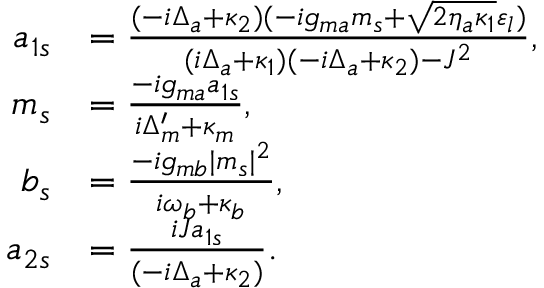Convert formula to latex. <formula><loc_0><loc_0><loc_500><loc_500>\begin{array} { r l } { a _ { 1 s } } & { = \frac { ( - i \Delta _ { a } + \kappa _ { 2 } ) ( - i g _ { m a } m _ { s } + \sqrt { 2 \eta _ { a } \kappa _ { 1 } } \varepsilon _ { l } ) } { ( i \Delta _ { a } + \kappa _ { 1 } ) ( - i \Delta _ { a } + \kappa _ { 2 } ) - J ^ { 2 } } , } \\ { m _ { s } } & { = \frac { - i g _ { m a } a _ { 1 s } } { i \Delta _ { m } ^ { \prime } + \kappa _ { m } } , } \\ { b _ { s } } & { = \frac { - i g _ { m b } | m _ { s } | ^ { 2 } } { i \omega _ { b } + \kappa _ { b } } , } \\ { a _ { 2 s } } & { = \frac { i J a _ { 1 s } } { ( - i \Delta _ { a } + \kappa _ { 2 } ) } . } \end{array}</formula> 